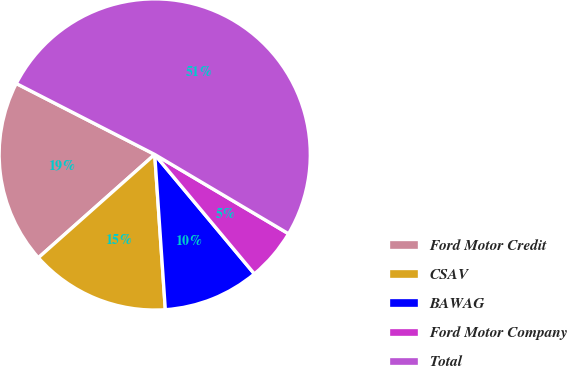Convert chart. <chart><loc_0><loc_0><loc_500><loc_500><pie_chart><fcel>Ford Motor Credit<fcel>CSAV<fcel>BAWAG<fcel>Ford Motor Company<fcel>Total<nl><fcel>19.09%<fcel>14.53%<fcel>9.98%<fcel>5.42%<fcel>50.97%<nl></chart> 